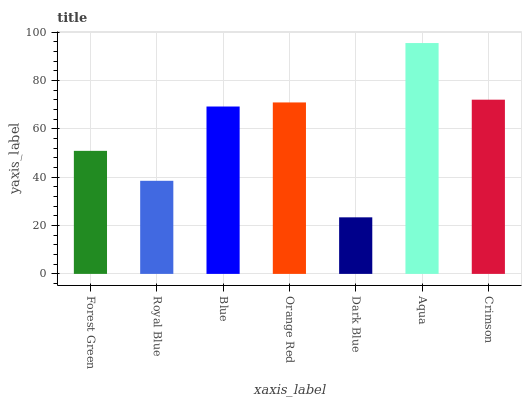Is Aqua the maximum?
Answer yes or no. Yes. Is Royal Blue the minimum?
Answer yes or no. No. Is Royal Blue the maximum?
Answer yes or no. No. Is Forest Green greater than Royal Blue?
Answer yes or no. Yes. Is Royal Blue less than Forest Green?
Answer yes or no. Yes. Is Royal Blue greater than Forest Green?
Answer yes or no. No. Is Forest Green less than Royal Blue?
Answer yes or no. No. Is Blue the high median?
Answer yes or no. Yes. Is Blue the low median?
Answer yes or no. Yes. Is Aqua the high median?
Answer yes or no. No. Is Forest Green the low median?
Answer yes or no. No. 